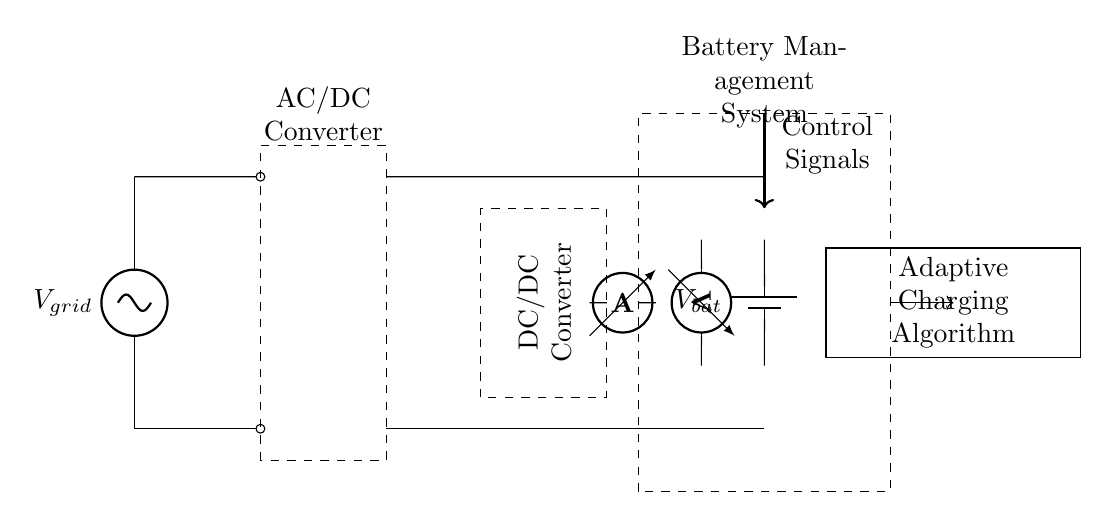What is the type of source connected to the grid? The circuit diagram shows a voltage source labeled V grid, indicating that it is an AC voltage source providing power to the system.
Answer: AC voltage What is the purpose of the AC/DC converter? The AC/DC converter transforms the alternating current from the grid into direct current, which is essential for charging the batteries and other components in the system.
Answer: Convert AC to DC How many converters are present in this circuit? There are two converters depicted in the diagram: an AC/DC converter and a DC/DC converter, each serving different roles in processing electrical energy.
Answer: Two converters What component measures the current flowing through the circuit? The ammeter is the instrument shown in the diagram that is specifically designed to measure the current, located between the DC/DC converter and the battery management system.
Answer: Ammeter What role does the control unit play in this system? The control unit sends signals to the battery management system, allowing it to adaptively manage the charging process based on various parameters like voltage, current, and temperature.
Answer: Manage charging Which component is responsible for adapting the charging process? The adaptive charging algorithm receives data from sensors and adjusts the charging parameters accordingly, making it crucial for optimizing the charging efficiency of the battery system.
Answer: Adaptive charging algorithm What is measured by the voltmeter in this circuit? The voltmeter measures the voltage across the battery, providing crucial information about the state of charge and ensuring that the battery operates within safe voltage limits.
Answer: Battery voltage 